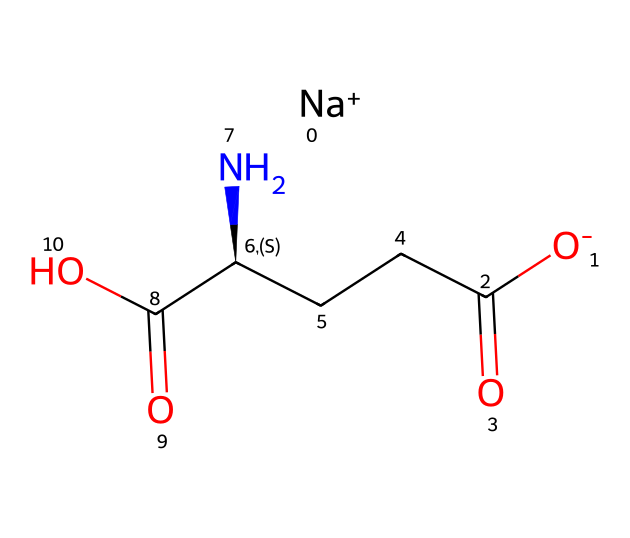What is the molecular formula of monosodium glutamate? By dissecting the SMILES representation, we identify the key elements present: carbon (C), hydrogen (H), nitrogen (N), oxygen (O), and sodium (Na). The count of these elements leads us to the formula C5H8N1O4Na.
Answer: C5H8N1O4Na How many carbon atoms are in the structure? Counting the 'C' in the SMILES notation shows that there are 5 carbon atoms present in the structure.
Answer: 5 What is the role of sodium in monosodium glutamate? The "Na+" in the structure indicates that sodium is a cation. In monosodium glutamate, sodium enhances solubility and reduces the bitter flavor of glutamate, contributing to the umami taste.
Answer: cation In which functional group does the nitrogen atom belong? The nitrogen atom (N) is part of an amine group (NH2) that contributes to the amino acid nature of glutamate and is typically associated with the amino group in such compounds.
Answer: amine How many oxygen atoms are present in the chemical? The "O" symbols in the SMILES string indicate that there are 4 oxygen atoms in total within the molecule.
Answer: 4 What type of compound is monosodium glutamate classified as? Given that it is a sodium salt of an amino acid (specifically glutamic acid), monosodium glutamate is classified as a food additive or flavor enhancer.
Answer: food additive What kind of taste does monosodium glutamate provide in foods? Monosodium glutamate is well known to provide an umami taste, which is a savory flavor distinct from the basic tastes of sweet, sour, salty, and bitter.
Answer: umami 